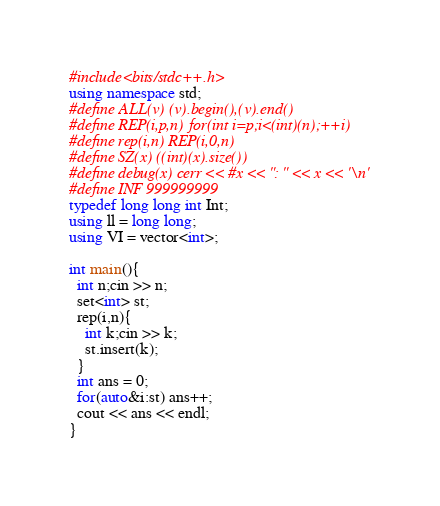<code> <loc_0><loc_0><loc_500><loc_500><_C++_>#include<bits/stdc++.h>
using namespace std;
#define ALL(v) (v).begin(),(v).end()
#define REP(i,p,n) for(int i=p;i<(int)(n);++i)
#define rep(i,n) REP(i,0,n)
#define SZ(x) ((int)(x).size())
#define debug(x) cerr << #x << ": " << x << '\n'
#define INF 999999999
typedef long long int Int;
using ll = long long;
using VI = vector<int>;

int main(){
  int n;cin >> n;
  set<int> st;
  rep(i,n){
    int k;cin >> k;
    st.insert(k);
  }
  int ans = 0;
  for(auto&i:st) ans++;
  cout << ans << endl;
}
</code> 